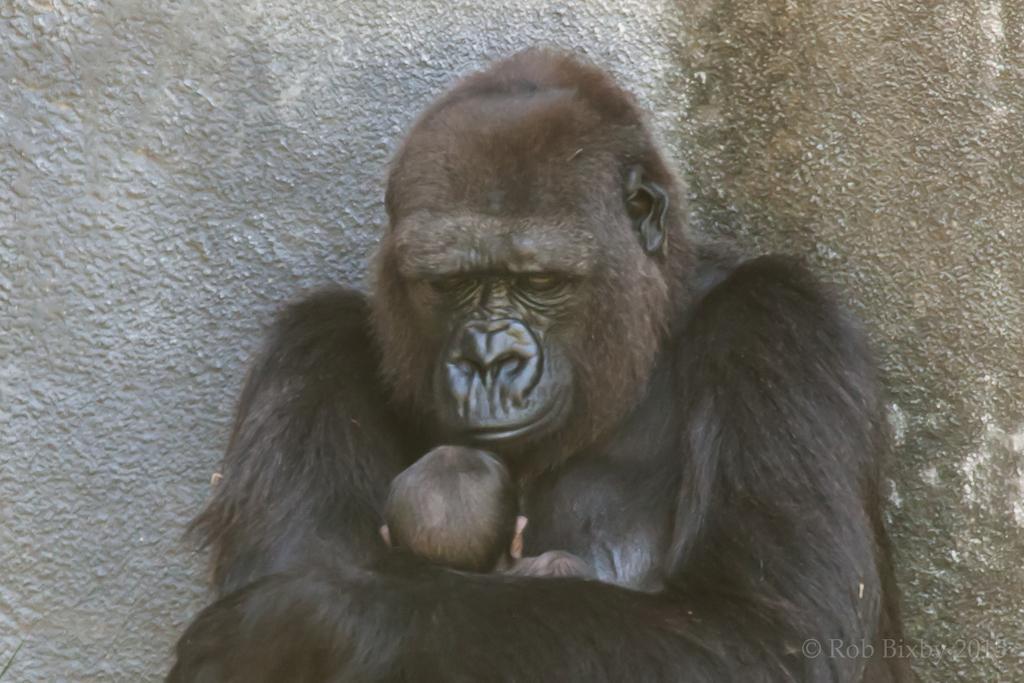Could you give a brief overview of what you see in this image? In the picture I can see the gorilla is carrying an infant. In the background, I can see the wall. Here I can see the watermark on the bottom right side of the image. 